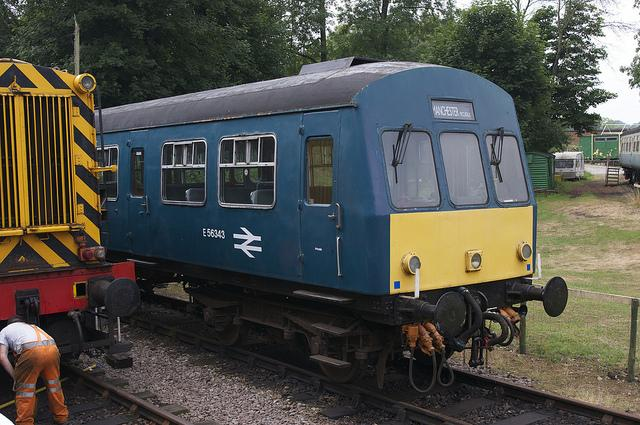What are the black circular pieces on the front of the train? bumpers 